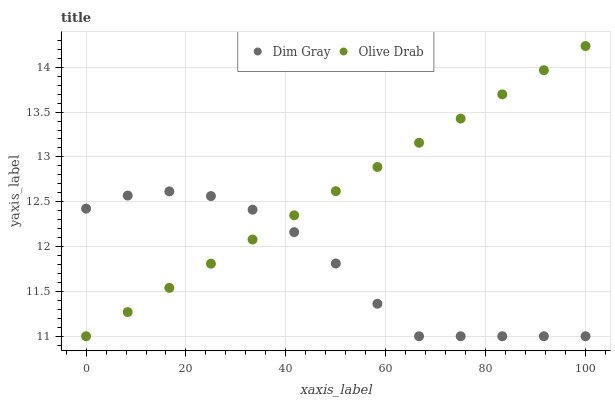Does Dim Gray have the minimum area under the curve?
Answer yes or no. Yes. Does Olive Drab have the maximum area under the curve?
Answer yes or no. Yes. Does Olive Drab have the minimum area under the curve?
Answer yes or no. No. Is Olive Drab the smoothest?
Answer yes or no. Yes. Is Dim Gray the roughest?
Answer yes or no. Yes. Is Olive Drab the roughest?
Answer yes or no. No. Does Dim Gray have the lowest value?
Answer yes or no. Yes. Does Olive Drab have the highest value?
Answer yes or no. Yes. Does Olive Drab intersect Dim Gray?
Answer yes or no. Yes. Is Olive Drab less than Dim Gray?
Answer yes or no. No. Is Olive Drab greater than Dim Gray?
Answer yes or no. No. 